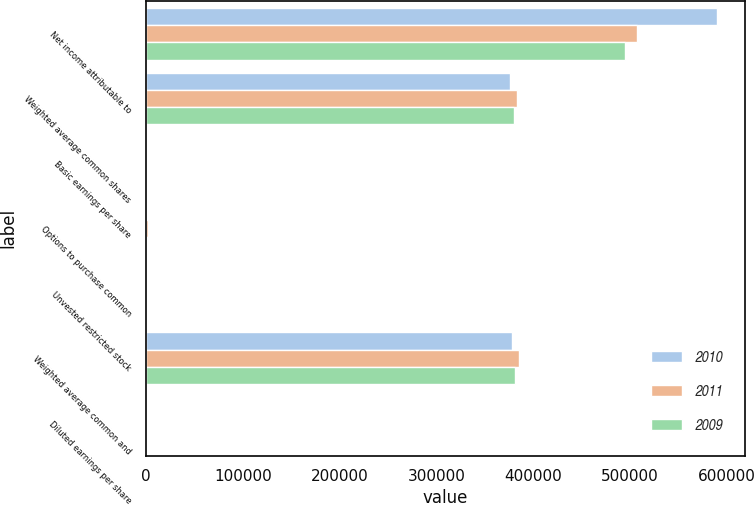Convert chart to OTSL. <chart><loc_0><loc_0><loc_500><loc_500><stacked_bar_chart><ecel><fcel>Net income attributable to<fcel>Weighted average common shares<fcel>Basic earnings per share<fcel>Options to purchase common<fcel>Unvested restricted stock<fcel>Weighted average common and<fcel>Diluted earnings per share<nl><fcel>2010<fcel>589200<fcel>375961<fcel>1.57<fcel>1495<fcel>149<fcel>377605<fcel>1.56<nl><fcel>2011<fcel>506500<fcel>382985<fcel>1.32<fcel>1895<fcel>231<fcel>385111<fcel>1.32<nl><fcel>2009<fcel>495000<fcel>379749<fcel>1.3<fcel>1172<fcel>40<fcel>380961<fcel>1.3<nl></chart> 